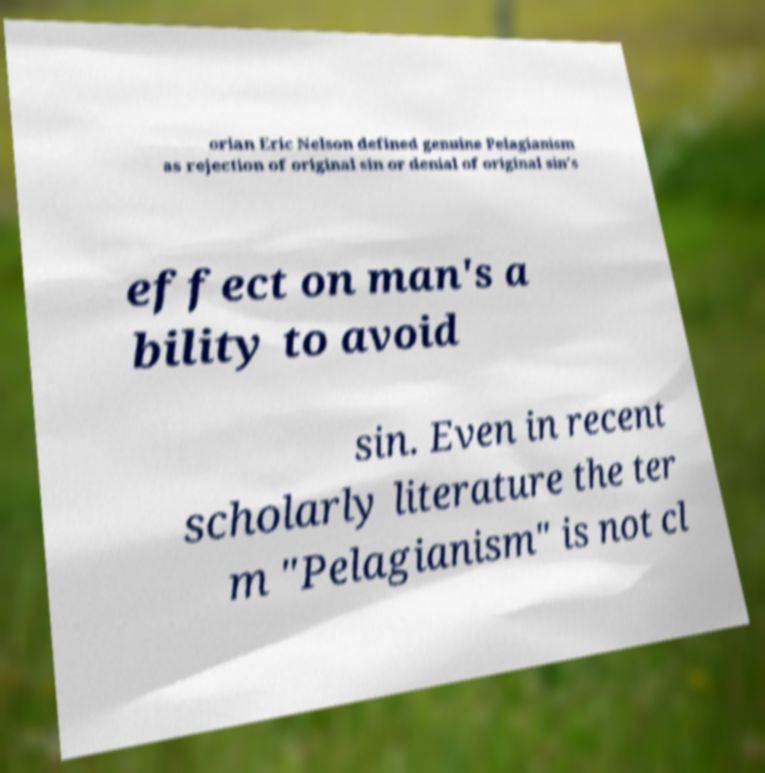I need the written content from this picture converted into text. Can you do that? orian Eric Nelson defined genuine Pelagianism as rejection of original sin or denial of original sin's effect on man's a bility to avoid sin. Even in recent scholarly literature the ter m "Pelagianism" is not cl 